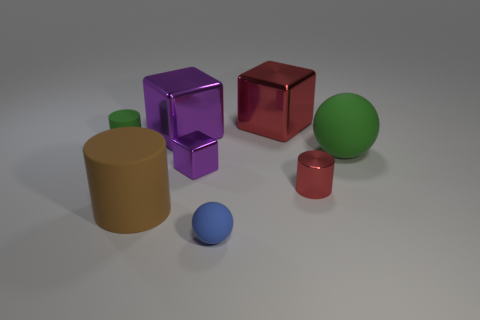Add 1 big red balls. How many objects exist? 9 Subtract all cylinders. How many objects are left? 5 Add 4 purple shiny things. How many purple shiny things exist? 6 Subtract 0 cyan balls. How many objects are left? 8 Subtract all metallic things. Subtract all small green things. How many objects are left? 3 Add 1 red objects. How many red objects are left? 3 